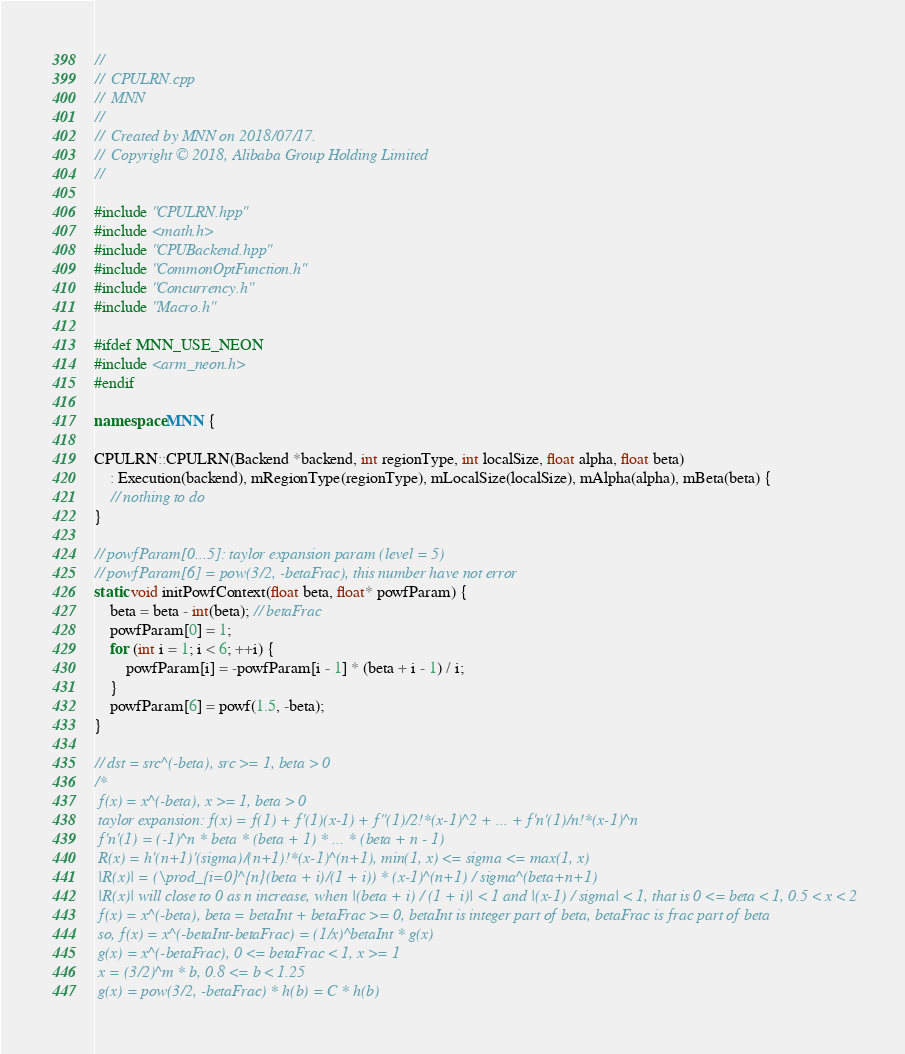<code> <loc_0><loc_0><loc_500><loc_500><_C++_>//
//  CPULRN.cpp
//  MNN
//
//  Created by MNN on 2018/07/17.
//  Copyright © 2018, Alibaba Group Holding Limited
//

#include "CPULRN.hpp"
#include <math.h>
#include "CPUBackend.hpp"
#include "CommonOptFunction.h"
#include "Concurrency.h"
#include "Macro.h"

#ifdef MNN_USE_NEON
#include <arm_neon.h>
#endif

namespace MNN {

CPULRN::CPULRN(Backend *backend, int regionType, int localSize, float alpha, float beta)
    : Execution(backend), mRegionType(regionType), mLocalSize(localSize), mAlpha(alpha), mBeta(beta) {
    // nothing to do
}

// powfParam[0...5]: taylor expansion param (level = 5)
// powfParam[6] = pow(3/2, -betaFrac), this number have not error
static void initPowfContext(float beta, float* powfParam) {
    beta = beta - int(beta); // betaFrac
    powfParam[0] = 1;
    for (int i = 1; i < 6; ++i) {
        powfParam[i] = -powfParam[i - 1] * (beta + i - 1) / i;
    }
    powfParam[6] = powf(1.5, -beta);
}
    
// dst = src^(-beta), src >= 1, beta > 0
/*
 f(x) = x^(-beta), x >= 1, beta > 0
 taylor expansion: f(x) = f(1) + f'(1)(x-1) + f''(1)/2!*(x-1)^2 + ... + f'n'(1)/n!*(x-1)^n
 f'n'(1) = (-1)^n * beta * (beta + 1) * ... * (beta + n - 1)
 R(x) = h'(n+1)'(sigma)/(n+1)!*(x-1)^(n+1), min(1, x) <= sigma <= max(1, x)
 |R(x)| = (\prod_{i=0}^{n}(beta + i)/(1 + i)) * (x-1)^(n+1) / sigma^(beta+n+1)
 |R(x)| will close to 0 as n increase, when |(beta + i) / (1 + i)| < 1 and |(x-1) / sigma| < 1, that is 0 <= beta < 1, 0.5 < x < 2
 f(x) = x^(-beta), beta = betaInt + betaFrac >= 0, betaInt is integer part of beta, betaFrac is frac part of beta
 so, f(x) = x^(-betaInt-betaFrac) = (1/x)^betaInt * g(x)
 g(x) = x^(-betaFrac), 0 <= betaFrac < 1, x >= 1
 x = (3/2)^m * b, 0.8 <= b < 1.25
 g(x) = pow(3/2, -betaFrac) * h(b) = C * h(b)</code> 